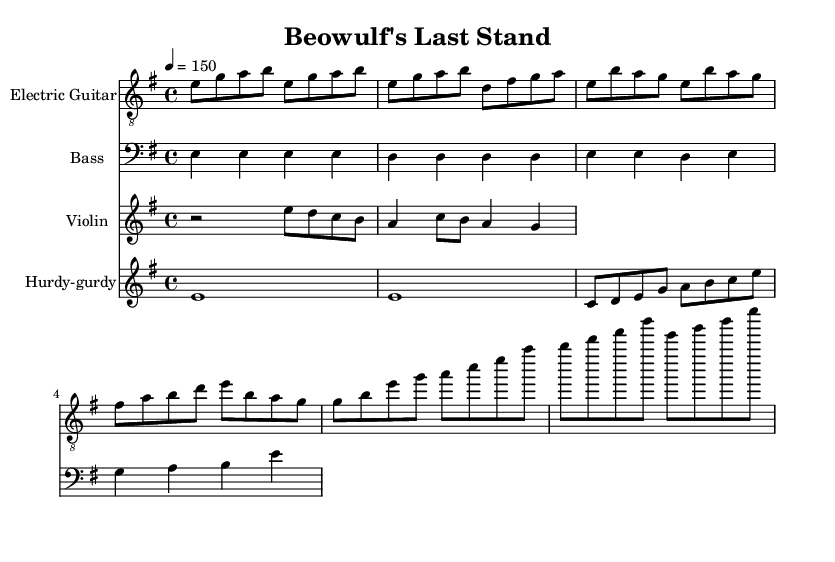What is the key signature of this music? The key signature is E minor, which has one sharp (F sharp) and is indicated at the beginning of the staff.
Answer: E minor What is the time signature of this music? The time signature is 4/4, which is indicated at the beginning and means there are four beats in each measure, and the quarter note gets one beat.
Answer: 4/4 What is the tempo marking for this composition? The tempo marking is indicated as "4 = 150," meaning the quarter note is set at a metronome mark of 150 beats per minute.
Answer: 150 How many measures are in the electric guitar part's intro? The electric guitar part’s intro consists of three measures, as indicated by the grouping of notes before the verse starts.
Answer: 3 What instrument plays the drone notes? The drone notes are played by the hurdy-gurdy, which is indicated in the sheet music with the designated staff for it.
Answer: Hurdy-gurdy Which section of the song features a counter-melody? The counter-melody is featured in the chorus, as indicated by its placement following the main melodic line within the violin staff.
Answer: Chorus What genre does "Beowulf's Last Stand" fit into? The piece fits into the folk metal genre, characterized by the combination of traditional folk elements with heavy metal instrumentation and themes drawn from folklore and mythology.
Answer: Folk metal 